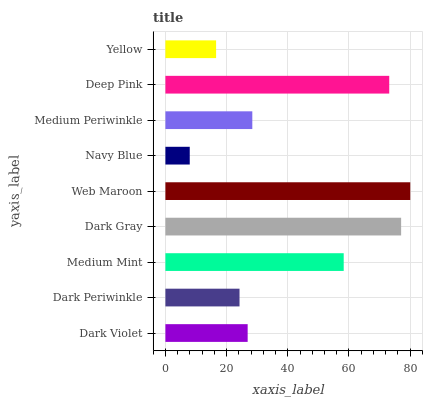Is Navy Blue the minimum?
Answer yes or no. Yes. Is Web Maroon the maximum?
Answer yes or no. Yes. Is Dark Periwinkle the minimum?
Answer yes or no. No. Is Dark Periwinkle the maximum?
Answer yes or no. No. Is Dark Violet greater than Dark Periwinkle?
Answer yes or no. Yes. Is Dark Periwinkle less than Dark Violet?
Answer yes or no. Yes. Is Dark Periwinkle greater than Dark Violet?
Answer yes or no. No. Is Dark Violet less than Dark Periwinkle?
Answer yes or no. No. Is Medium Periwinkle the high median?
Answer yes or no. Yes. Is Medium Periwinkle the low median?
Answer yes or no. Yes. Is Navy Blue the high median?
Answer yes or no. No. Is Dark Periwinkle the low median?
Answer yes or no. No. 